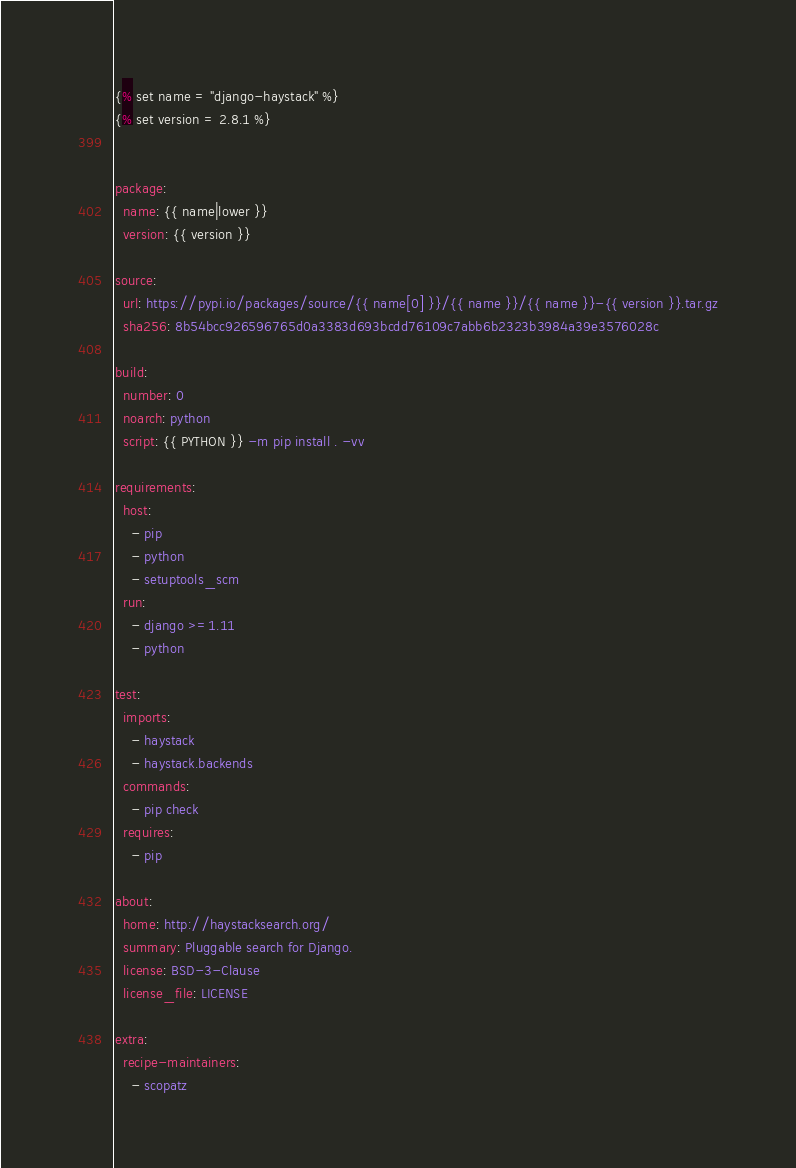Convert code to text. <code><loc_0><loc_0><loc_500><loc_500><_YAML_>{% set name = "django-haystack" %}
{% set version = 2.8.1 %}


package:
  name: {{ name|lower }}
  version: {{ version }}

source:
  url: https://pypi.io/packages/source/{{ name[0] }}/{{ name }}/{{ name }}-{{ version }}.tar.gz
  sha256: 8b54bcc926596765d0a3383d693bcdd76109c7abb6b2323b3984a39e3576028c

build:
  number: 0
  noarch: python
  script: {{ PYTHON }} -m pip install . -vv

requirements:
  host:
    - pip
    - python
    - setuptools_scm
  run:
    - django >=1.11
    - python

test:
  imports:
    - haystack
    - haystack.backends
  commands:
    - pip check
  requires:
    - pip

about:
  home: http://haystacksearch.org/
  summary: Pluggable search for Django.
  license: BSD-3-Clause
  license_file: LICENSE

extra:
  recipe-maintainers:
    - scopatz
</code> 